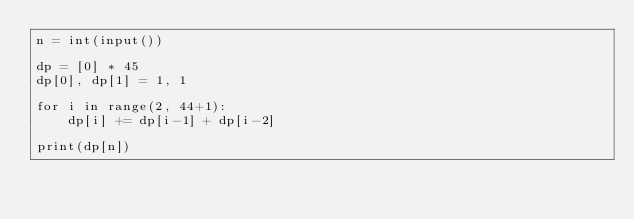Convert code to text. <code><loc_0><loc_0><loc_500><loc_500><_Python_>n = int(input())

dp = [0] * 45
dp[0], dp[1] = 1, 1

for i in range(2, 44+1):
    dp[i] += dp[i-1] + dp[i-2]

print(dp[n])
</code> 